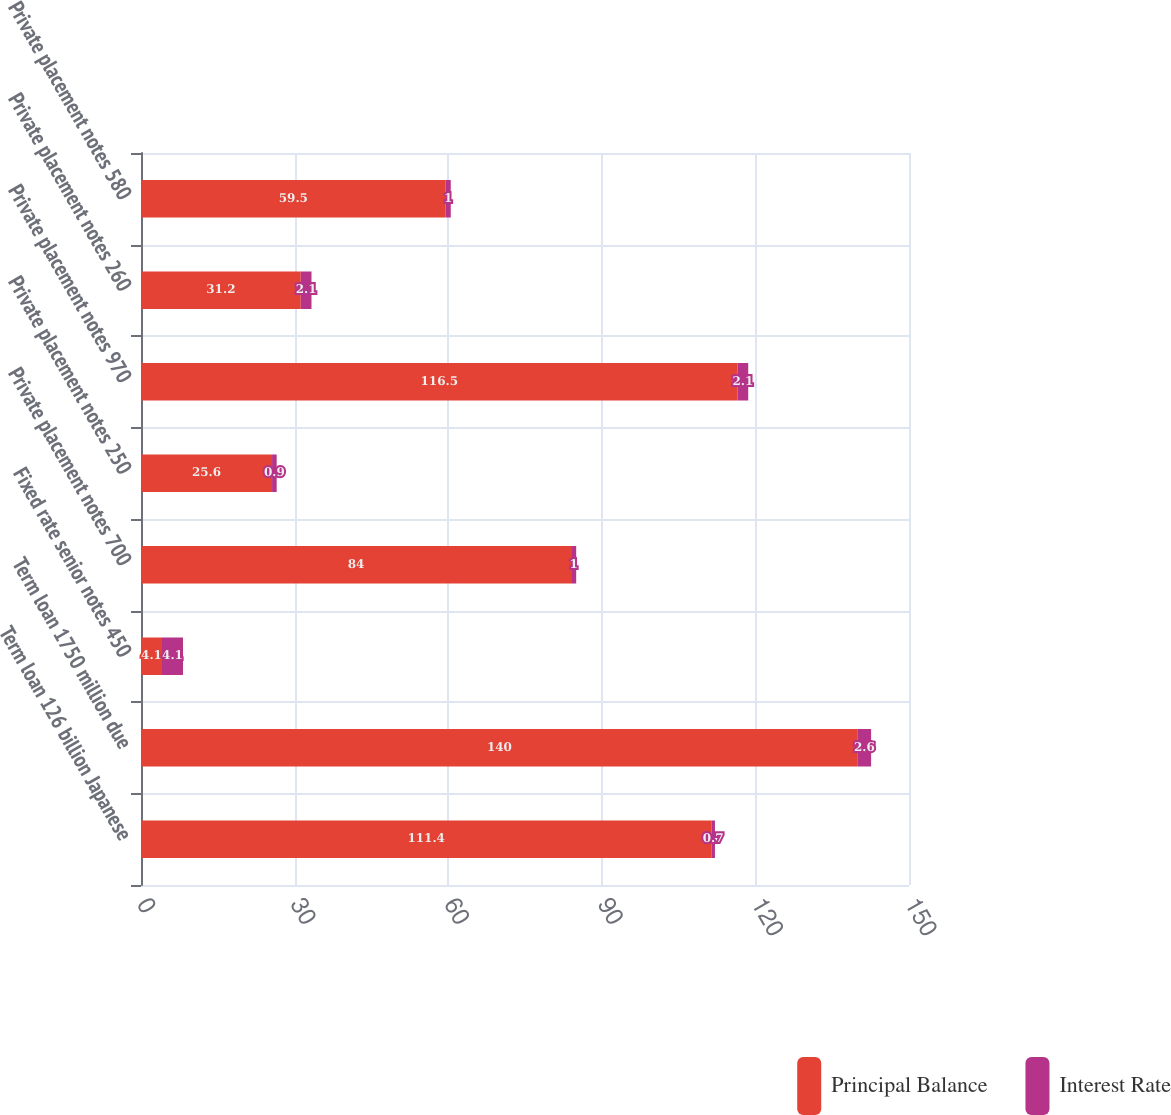<chart> <loc_0><loc_0><loc_500><loc_500><stacked_bar_chart><ecel><fcel>Term loan 126 billion Japanese<fcel>Term loan 1750 million due<fcel>Fixed rate senior notes 450<fcel>Private placement notes 700<fcel>Private placement notes 250<fcel>Private placement notes 970<fcel>Private placement notes 260<fcel>Private placement notes 580<nl><fcel>Principal Balance<fcel>111.4<fcel>140<fcel>4.1<fcel>84<fcel>25.6<fcel>116.5<fcel>31.2<fcel>59.5<nl><fcel>Interest Rate<fcel>0.7<fcel>2.6<fcel>4.1<fcel>1<fcel>0.9<fcel>2.1<fcel>2.1<fcel>1<nl></chart> 